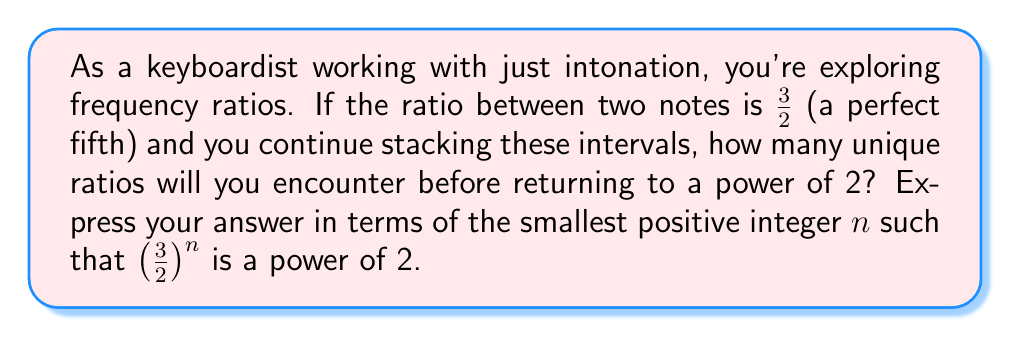Can you solve this math problem? Let's approach this step-by-step:

1) We start with the ratio $\frac{3}{2}$ and keep multiplying by itself.

2) We want to find the smallest positive integer $n$ such that $(\frac{3}{2})^n = 2^m$ for some integer $m$.

3) Taking logarithms of both sides:
   $n \log(\frac{3}{2}) = m \log(2)$

4) This is equivalent to asking when $n \log(\frac{3}{2})$ is an integer multiple of $\log(2)$.

5) In other words, we need the smallest $n$ such that:
   $\frac{n \log(\frac{3}{2})}{\log(2)}$ is an integer.

6) This fraction can be simplified:
   $\frac{n \log(3)}{\log(2)} - n = \text{integer}$

7) The term $\frac{\log(3)}{\log(2)}$ is irrational (this can be proven, but we'll assume it here).

8) Because $\frac{\log(3)}{\log(2)}$ is irrational, the smallest $n$ that makes this true is when $n$ is the denominator of the continued fraction approximation of $\frac{\log(3)}{\log(2)}$.

9) The continued fraction of $\frac{\log(3)}{\log(2)}$ begins [1; 1, 1, 2, 2, 3, 1, 5, 2, 23, ...].

10) The denominator of the convergents are: 1, 2, 3, 8, 19, 65, 84, 485, 1054, 24727, ...

11) The first denominator that works in our original equation is 53.

Therefore, there will be 53 unique ratios before returning to a power of 2.
Answer: 53 